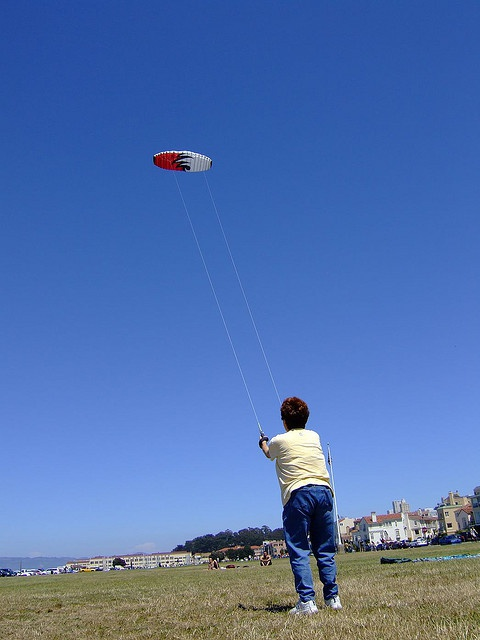Describe the objects in this image and their specific colors. I can see people in blue, black, beige, navy, and gray tones, kite in blue, darkgray, maroon, brown, and black tones, car in blue, navy, and black tones, people in blue, black, maroon, and gray tones, and car in blue, navy, darkgray, white, and black tones in this image. 